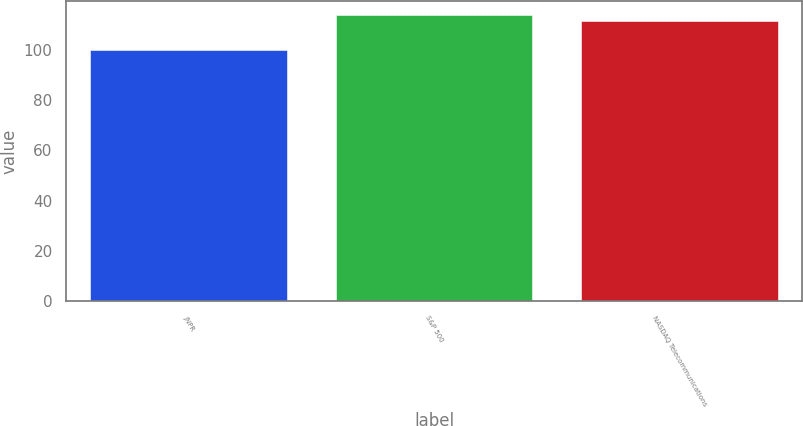<chart> <loc_0><loc_0><loc_500><loc_500><bar_chart><fcel>JNPR<fcel>S&P 500<fcel>NASDAQ Telecommunications<nl><fcel>99.77<fcel>113.68<fcel>111.51<nl></chart> 